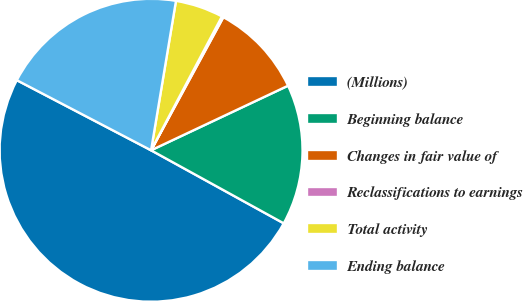Convert chart. <chart><loc_0><loc_0><loc_500><loc_500><pie_chart><fcel>(Millions)<fcel>Beginning balance<fcel>Changes in fair value of<fcel>Reclassifications to earnings<fcel>Total activity<fcel>Ending balance<nl><fcel>49.65%<fcel>15.02%<fcel>10.07%<fcel>0.17%<fcel>5.12%<fcel>19.97%<nl></chart> 